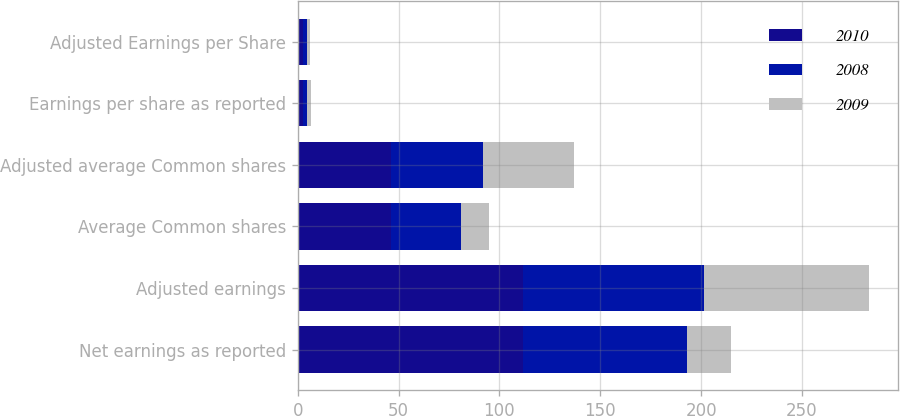Convert chart. <chart><loc_0><loc_0><loc_500><loc_500><stacked_bar_chart><ecel><fcel>Net earnings as reported<fcel>Adjusted earnings<fcel>Average Common shares<fcel>Adjusted average Common shares<fcel>Earnings per share as reported<fcel>Adjusted Earnings per Share<nl><fcel>2010<fcel>111.7<fcel>111.7<fcel>46.2<fcel>46.2<fcel>2.42<fcel>2.42<nl><fcel>2008<fcel>81.3<fcel>89.7<fcel>34.5<fcel>45.5<fcel>2.36<fcel>1.97<nl><fcel>2009<fcel>21.7<fcel>81.9<fcel>14.2<fcel>45.4<fcel>1.53<fcel>1.8<nl></chart> 